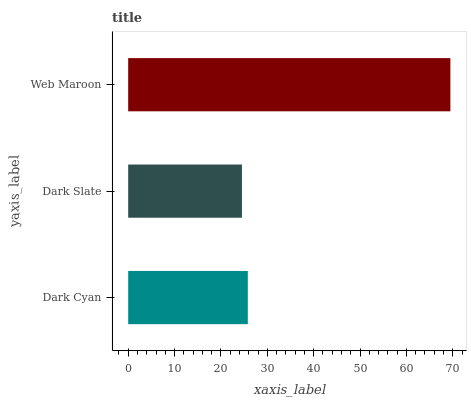Is Dark Slate the minimum?
Answer yes or no. Yes. Is Web Maroon the maximum?
Answer yes or no. Yes. Is Web Maroon the minimum?
Answer yes or no. No. Is Dark Slate the maximum?
Answer yes or no. No. Is Web Maroon greater than Dark Slate?
Answer yes or no. Yes. Is Dark Slate less than Web Maroon?
Answer yes or no. Yes. Is Dark Slate greater than Web Maroon?
Answer yes or no. No. Is Web Maroon less than Dark Slate?
Answer yes or no. No. Is Dark Cyan the high median?
Answer yes or no. Yes. Is Dark Cyan the low median?
Answer yes or no. Yes. Is Dark Slate the high median?
Answer yes or no. No. Is Dark Slate the low median?
Answer yes or no. No. 